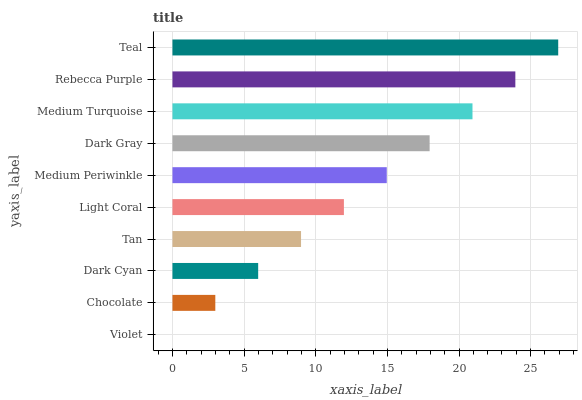Is Violet the minimum?
Answer yes or no. Yes. Is Teal the maximum?
Answer yes or no. Yes. Is Chocolate the minimum?
Answer yes or no. No. Is Chocolate the maximum?
Answer yes or no. No. Is Chocolate greater than Violet?
Answer yes or no. Yes. Is Violet less than Chocolate?
Answer yes or no. Yes. Is Violet greater than Chocolate?
Answer yes or no. No. Is Chocolate less than Violet?
Answer yes or no. No. Is Medium Periwinkle the high median?
Answer yes or no. Yes. Is Light Coral the low median?
Answer yes or no. Yes. Is Rebecca Purple the high median?
Answer yes or no. No. Is Tan the low median?
Answer yes or no. No. 